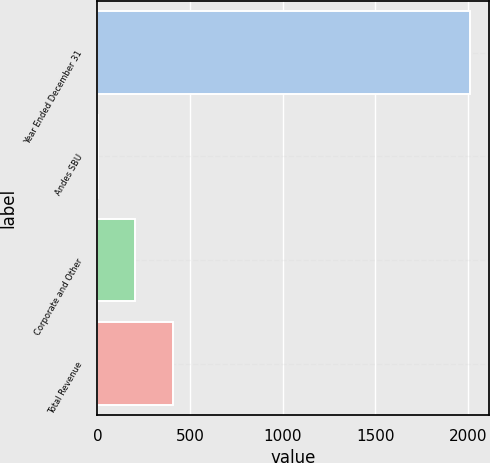<chart> <loc_0><loc_0><loc_500><loc_500><bar_chart><fcel>Year Ended December 31<fcel>Andes SBU<fcel>Corporate and Other<fcel>Total Revenue<nl><fcel>2014<fcel>4<fcel>205<fcel>406<nl></chart> 